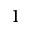<formula> <loc_0><loc_0><loc_500><loc_500>1</formula> 